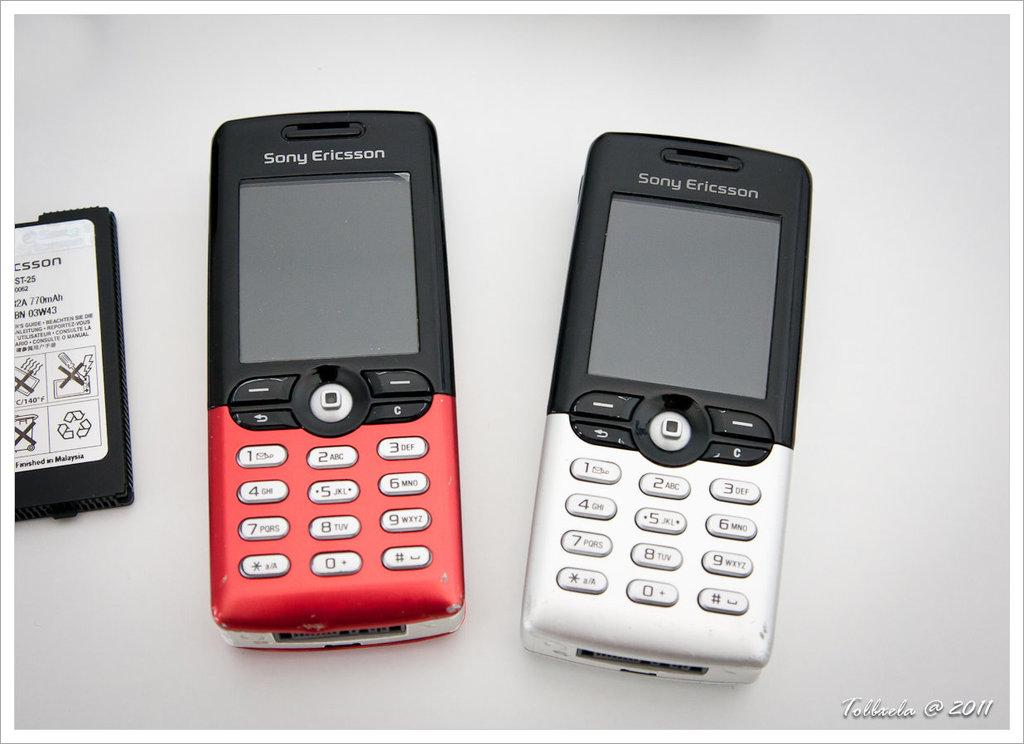<image>
Relay a brief, clear account of the picture shown. Two Sony Ericcson phones, one red and one silver. 